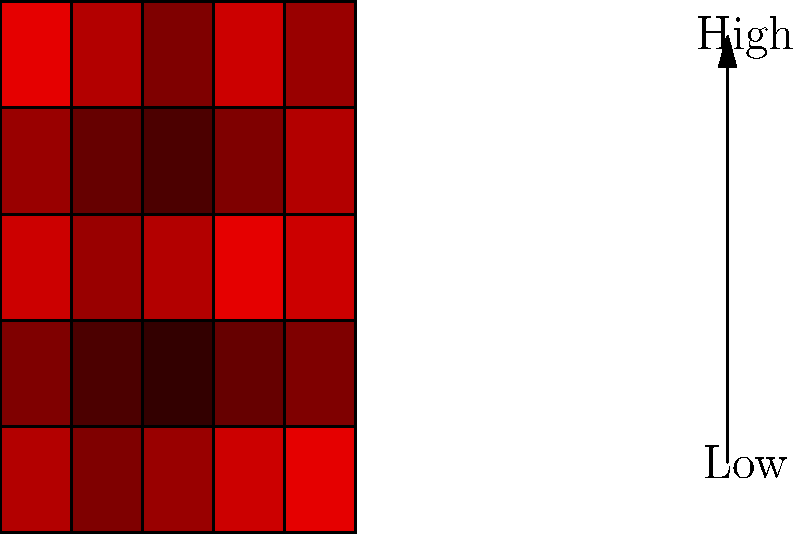Based on the heat map of nuclear proliferation risks in different regions, which area appears to be the most vulnerable, and what immediate policy measures should be considered to address this high-risk zone? To answer this question, we need to analyze the heat map and consider appropriate policy responses:

1. Analyze the heat map:
   - The map shows vulnerability levels across different regions.
   - Darker red indicates higher vulnerability.
   - The darkest red areas represent the highest risk zones.

2. Identify the most vulnerable area:
   - The darkest red appears in the top-right and bottom-right corners of the map.
   - These areas represent the highest risk for nuclear proliferation.

3. Consider immediate policy measures:
   a) Diplomatic engagement:
      - Initiate high-level talks with countries in the high-risk region.
      - Negotiate agreements to limit nuclear technology development.

   b) Economic incentives and sanctions:
      - Offer economic benefits for compliance with non-proliferation treaties.
      - Implement targeted sanctions on entities involved in proliferation activities.

   c) Intelligence and monitoring:
      - Enhance intelligence-gathering efforts in the high-risk area.
      - Strengthen international monitoring through organizations like the IAEA.

   d) Security assistance:
      - Provide support to improve nuclear material security in vulnerable countries.
      - Offer training and technology for better safeguards and containment.

   e) Multilateral cooperation:
      - Work with allies and international organizations to create a unified approach.
      - Strengthen existing non-proliferation frameworks and treaties.

4. Develop a comprehensive strategy:
   - Combine immediate measures with long-term plans to reduce proliferation risks.
   - Regularly reassess the situation and adjust policies as needed.
Answer: Immediate diplomatic engagement, enhanced monitoring, and security assistance in the top-right region. 